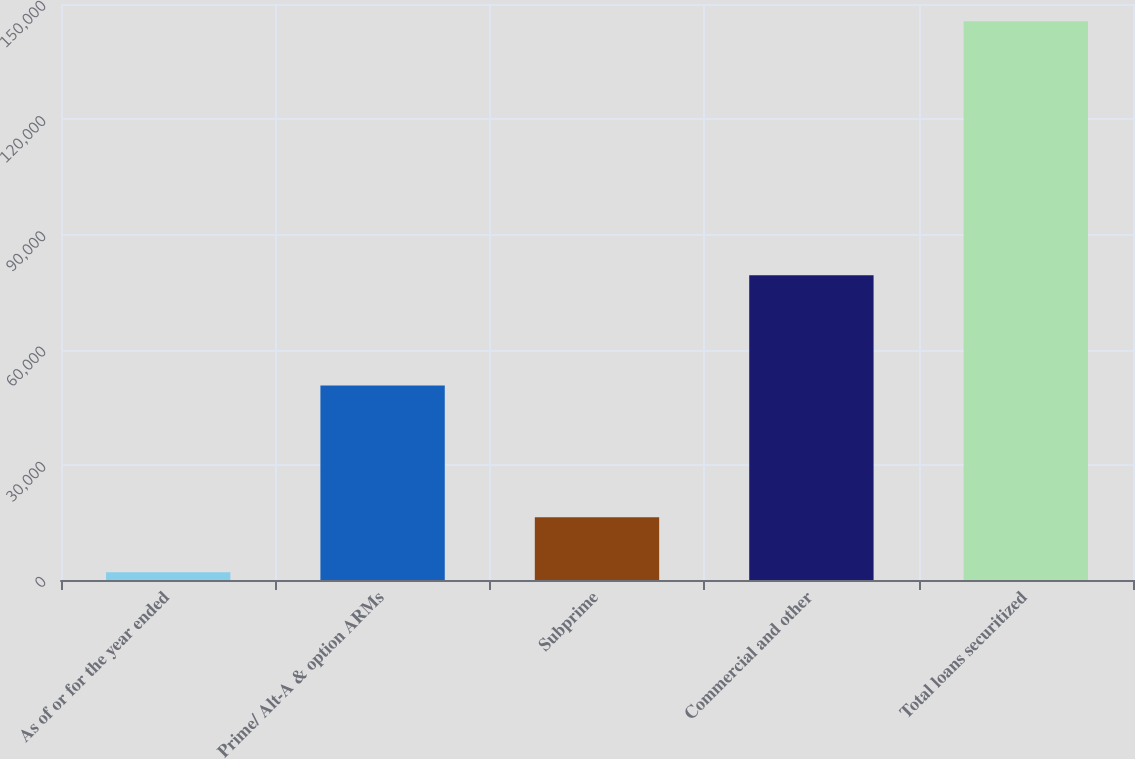<chart> <loc_0><loc_0><loc_500><loc_500><bar_chart><fcel>As of or for the year ended<fcel>Prime/ Alt-A & option ARMs<fcel>Subprime<fcel>Commercial and other<fcel>Total loans securitized<nl><fcel>2018<fcel>50679<fcel>16366.2<fcel>79387<fcel>145500<nl></chart> 